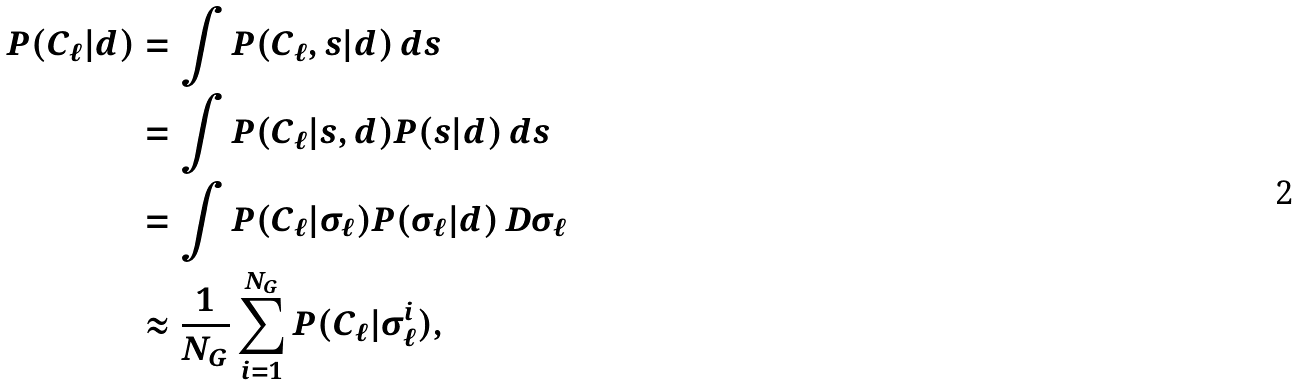<formula> <loc_0><loc_0><loc_500><loc_500>P ( C _ { \ell } | d ) & = \int P ( C _ { \ell } , s | d ) \, d s \\ & = \int P ( C _ { \ell } | s , d ) P ( s | d ) \, d s \\ & = \int P ( C _ { \ell } | \sigma _ { \ell } ) P ( \sigma _ { \ell } | d ) \, D \sigma _ { \ell } \\ & \approx \frac { 1 } { N _ { G } } \sum _ { i = 1 } ^ { N _ { G } } P ( C _ { \ell } | \sigma _ { \ell } ^ { i } ) ,</formula> 